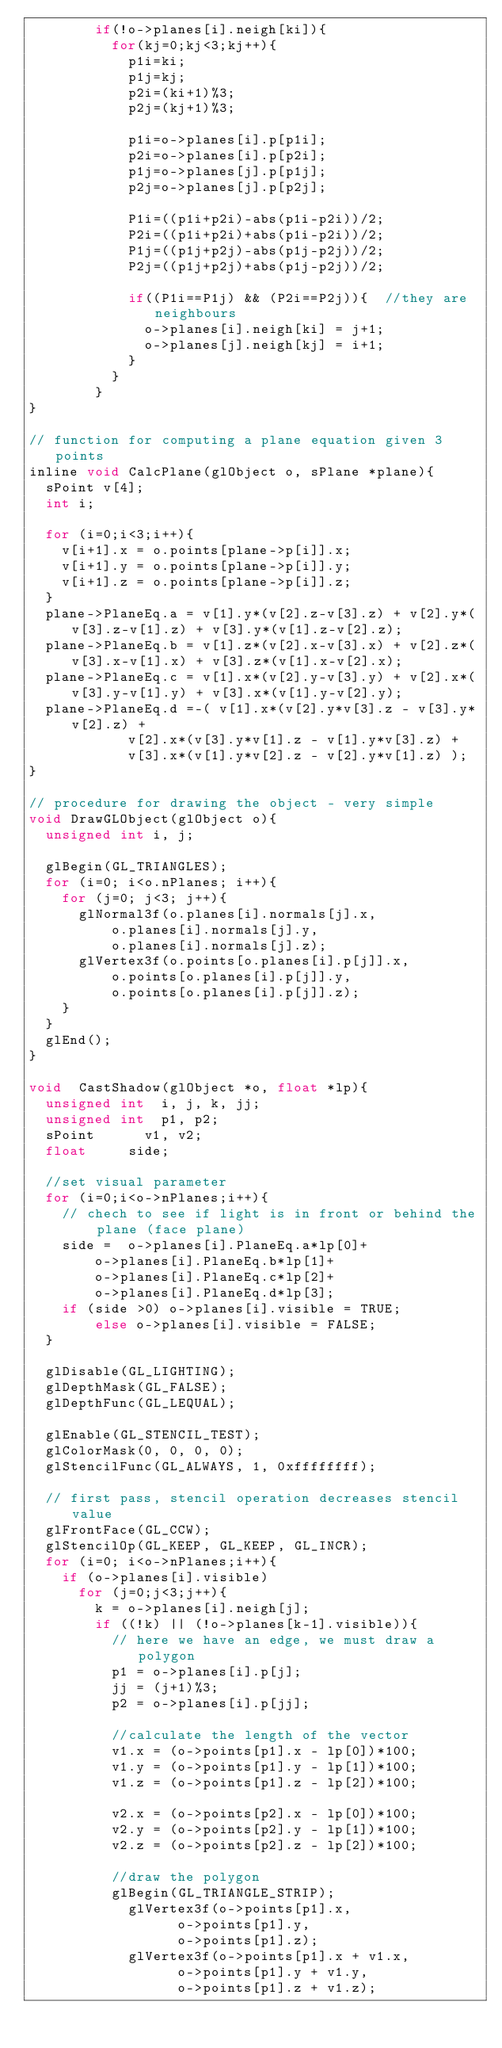<code> <loc_0><loc_0><loc_500><loc_500><_C_>				if(!o->planes[i].neigh[ki]){
					for(kj=0;kj<3;kj++){
						p1i=ki;
						p1j=kj;
						p2i=(ki+1)%3;
						p2j=(kj+1)%3;

						p1i=o->planes[i].p[p1i];
						p2i=o->planes[i].p[p2i];
						p1j=o->planes[j].p[p1j];
						p2j=o->planes[j].p[p2j];

						P1i=((p1i+p2i)-abs(p1i-p2i))/2;
						P2i=((p1i+p2i)+abs(p1i-p2i))/2;
						P1j=((p1j+p2j)-abs(p1j-p2j))/2;
						P2j=((p1j+p2j)+abs(p1j-p2j))/2;

						if((P1i==P1j) && (P2i==P2j)){  //they are neighbours
							o->planes[i].neigh[ki] = j+1;	  
							o->planes[j].neigh[kj] = i+1;	  
						}
					}
				}
}

// function for computing a plane equation given 3 points
inline void CalcPlane(glObject o, sPlane *plane){
	sPoint v[4];
	int i;

	for (i=0;i<3;i++){
		v[i+1].x = o.points[plane->p[i]].x;
		v[i+1].y = o.points[plane->p[i]].y;
		v[i+1].z = o.points[plane->p[i]].z;
	}
	plane->PlaneEq.a = v[1].y*(v[2].z-v[3].z) + v[2].y*(v[3].z-v[1].z) + v[3].y*(v[1].z-v[2].z);
	plane->PlaneEq.b = v[1].z*(v[2].x-v[3].x) + v[2].z*(v[3].x-v[1].x) + v[3].z*(v[1].x-v[2].x);
	plane->PlaneEq.c = v[1].x*(v[2].y-v[3].y) + v[2].x*(v[3].y-v[1].y) + v[3].x*(v[1].y-v[2].y);
	plane->PlaneEq.d =-( v[1].x*(v[2].y*v[3].z - v[3].y*v[2].z) +
					  v[2].x*(v[3].y*v[1].z - v[1].y*v[3].z) +
					  v[3].x*(v[1].y*v[2].z - v[2].y*v[1].z) );
}

// procedure for drawing the object - very simple
void DrawGLObject(glObject o){
	unsigned int i, j;

	glBegin(GL_TRIANGLES);
	for (i=0; i<o.nPlanes; i++){
		for (j=0; j<3; j++){
			glNormal3f(o.planes[i].normals[j].x,
					o.planes[i].normals[j].y,
					o.planes[i].normals[j].z);
			glVertex3f(o.points[o.planes[i].p[j]].x,
					o.points[o.planes[i].p[j]].y,
					o.points[o.planes[i].p[j]].z);
		}
	}
	glEnd();
}

void  CastShadow(glObject *o, float *lp){
	unsigned int	i, j, k, jj;
	unsigned int	p1, p2;
	sPoint			v1, v2;
	float			side;

	//set visual parameter
	for (i=0;i<o->nPlanes;i++){
		// chech to see if light is in front or behind the plane (face plane)
		side =	o->planes[i].PlaneEq.a*lp[0]+
				o->planes[i].PlaneEq.b*lp[1]+
				o->planes[i].PlaneEq.c*lp[2]+
				o->planes[i].PlaneEq.d*lp[3];
		if (side >0) o->planes[i].visible = TRUE;
				else o->planes[i].visible = FALSE;
	}

 	glDisable(GL_LIGHTING);
	glDepthMask(GL_FALSE);
	glDepthFunc(GL_LEQUAL);

	glEnable(GL_STENCIL_TEST);
	glColorMask(0, 0, 0, 0);
	glStencilFunc(GL_ALWAYS, 1, 0xffffffff);

	// first pass, stencil operation decreases stencil value
	glFrontFace(GL_CCW);
	glStencilOp(GL_KEEP, GL_KEEP, GL_INCR);
	for (i=0; i<o->nPlanes;i++){
		if (o->planes[i].visible)
			for (j=0;j<3;j++){
				k = o->planes[i].neigh[j];
				if ((!k) || (!o->planes[k-1].visible)){
					// here we have an edge, we must draw a polygon
					p1 = o->planes[i].p[j];
					jj = (j+1)%3;
					p2 = o->planes[i].p[jj];

					//calculate the length of the vector
					v1.x = (o->points[p1].x - lp[0])*100;
					v1.y = (o->points[p1].y - lp[1])*100;
					v1.z = (o->points[p1].z - lp[2])*100;

					v2.x = (o->points[p2].x - lp[0])*100;
					v2.y = (o->points[p2].y - lp[1])*100;
					v2.z = (o->points[p2].z - lp[2])*100;
					
					//draw the polygon
					glBegin(GL_TRIANGLE_STRIP);
						glVertex3f(o->points[p1].x,
									o->points[p1].y,
									o->points[p1].z);
						glVertex3f(o->points[p1].x + v1.x,
									o->points[p1].y + v1.y,
									o->points[p1].z + v1.z);
</code> 